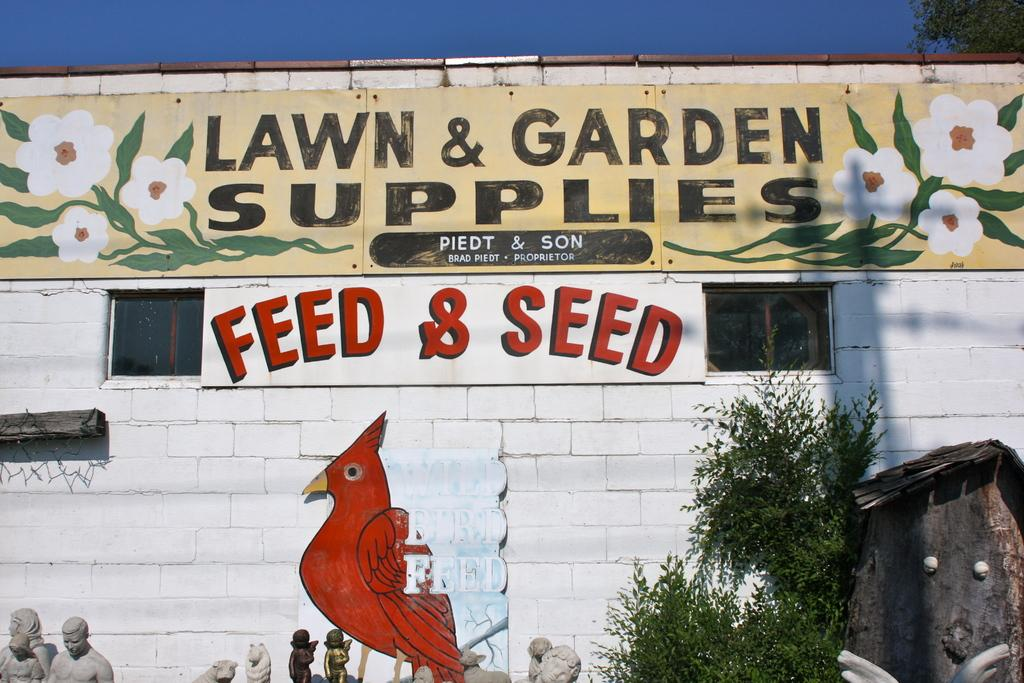What is depicted on the wall in the image? There is a painting on the wall in the image. What other features can be seen on the wall? There are windows on the wall in the image. What type of artwork is present in the image? There are sculptures in the image. What is the color of the sky in the image? The sky is blue in color in the image. What type of vegetation is on the right side of the image? There are plants on the right side of the image. What type of wool is being used to create the beam in the image? There is no wool or beam present in the image. What is the top of the painting in the image? The top of the painting is the upper edge of the depicted artwork in the image. 